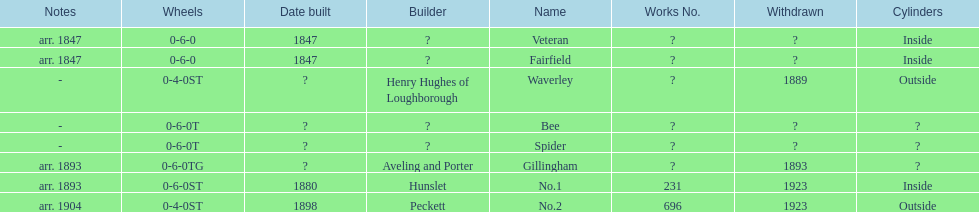What name is listed after spider? Gillingham. 